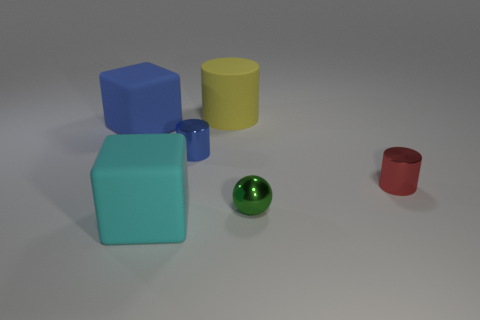Can you describe the shapes and colors of the objects in the image? Certainly! There are five objects present. Starting from the largest, there's a blue cube, a turquoise cuboid, a yellow cylinder, a green sphere, and a small red cup. Each has a distinct, solid color and a glossy surface finish. 